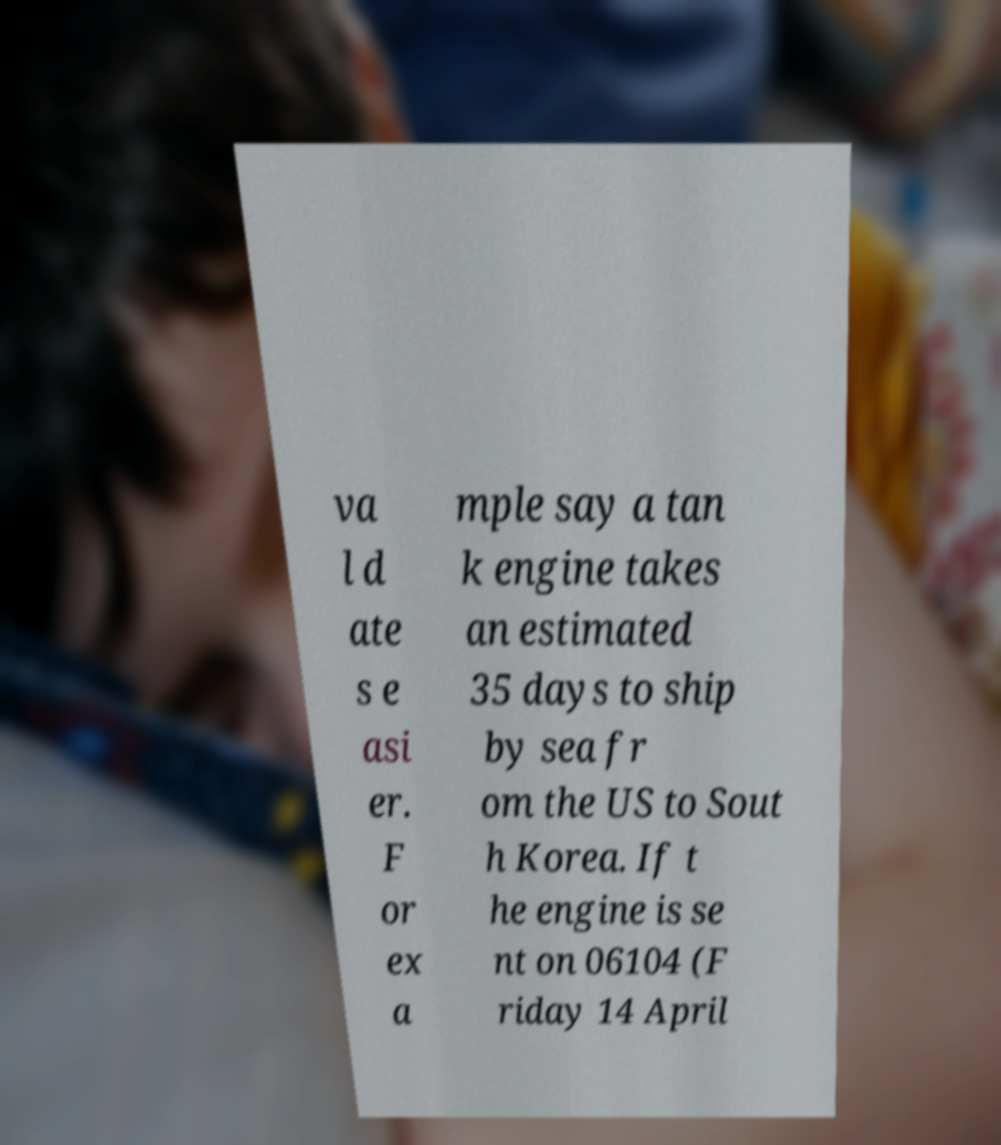Could you assist in decoding the text presented in this image and type it out clearly? va l d ate s e asi er. F or ex a mple say a tan k engine takes an estimated 35 days to ship by sea fr om the US to Sout h Korea. If t he engine is se nt on 06104 (F riday 14 April 